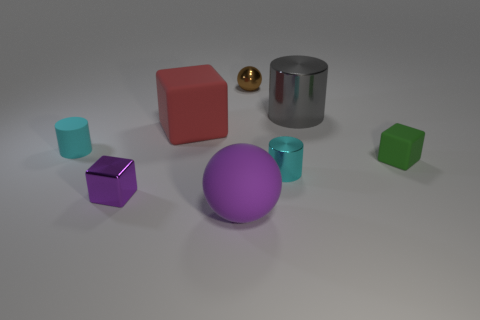What number of tiny objects are either gray shiny balls or red objects?
Your answer should be very brief. 0. Does the tiny green block have the same material as the brown thing?
Offer a very short reply. No. There is a sphere that is the same color as the tiny metallic cube; what size is it?
Give a very brief answer. Large. Are there any big shiny objects of the same color as the metallic block?
Provide a short and direct response. No. What is the size of the cyan thing that is the same material as the tiny sphere?
Your response must be concise. Small. There is a tiny cyan object that is on the left side of the cyan cylinder to the right of the cyan cylinder to the left of the brown thing; what shape is it?
Provide a short and direct response. Cylinder. There is a purple object that is the same shape as the green object; what size is it?
Your answer should be compact. Small. There is a shiny object that is both to the right of the big purple sphere and in front of the big gray thing; what size is it?
Your answer should be compact. Small. What is the shape of the small metallic object that is the same color as the large sphere?
Offer a terse response. Cube. The matte cylinder is what color?
Offer a very short reply. Cyan. 